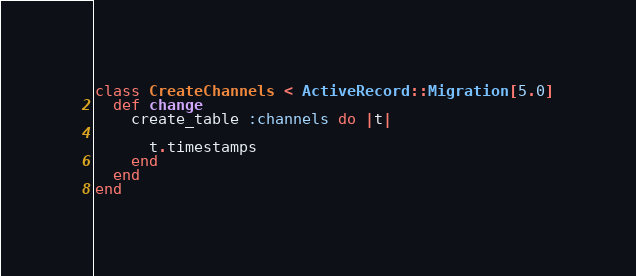Convert code to text. <code><loc_0><loc_0><loc_500><loc_500><_Ruby_>class CreateChannels < ActiveRecord::Migration[5.0]
  def change
    create_table :channels do |t|

      t.timestamps
    end
  end
end
</code> 